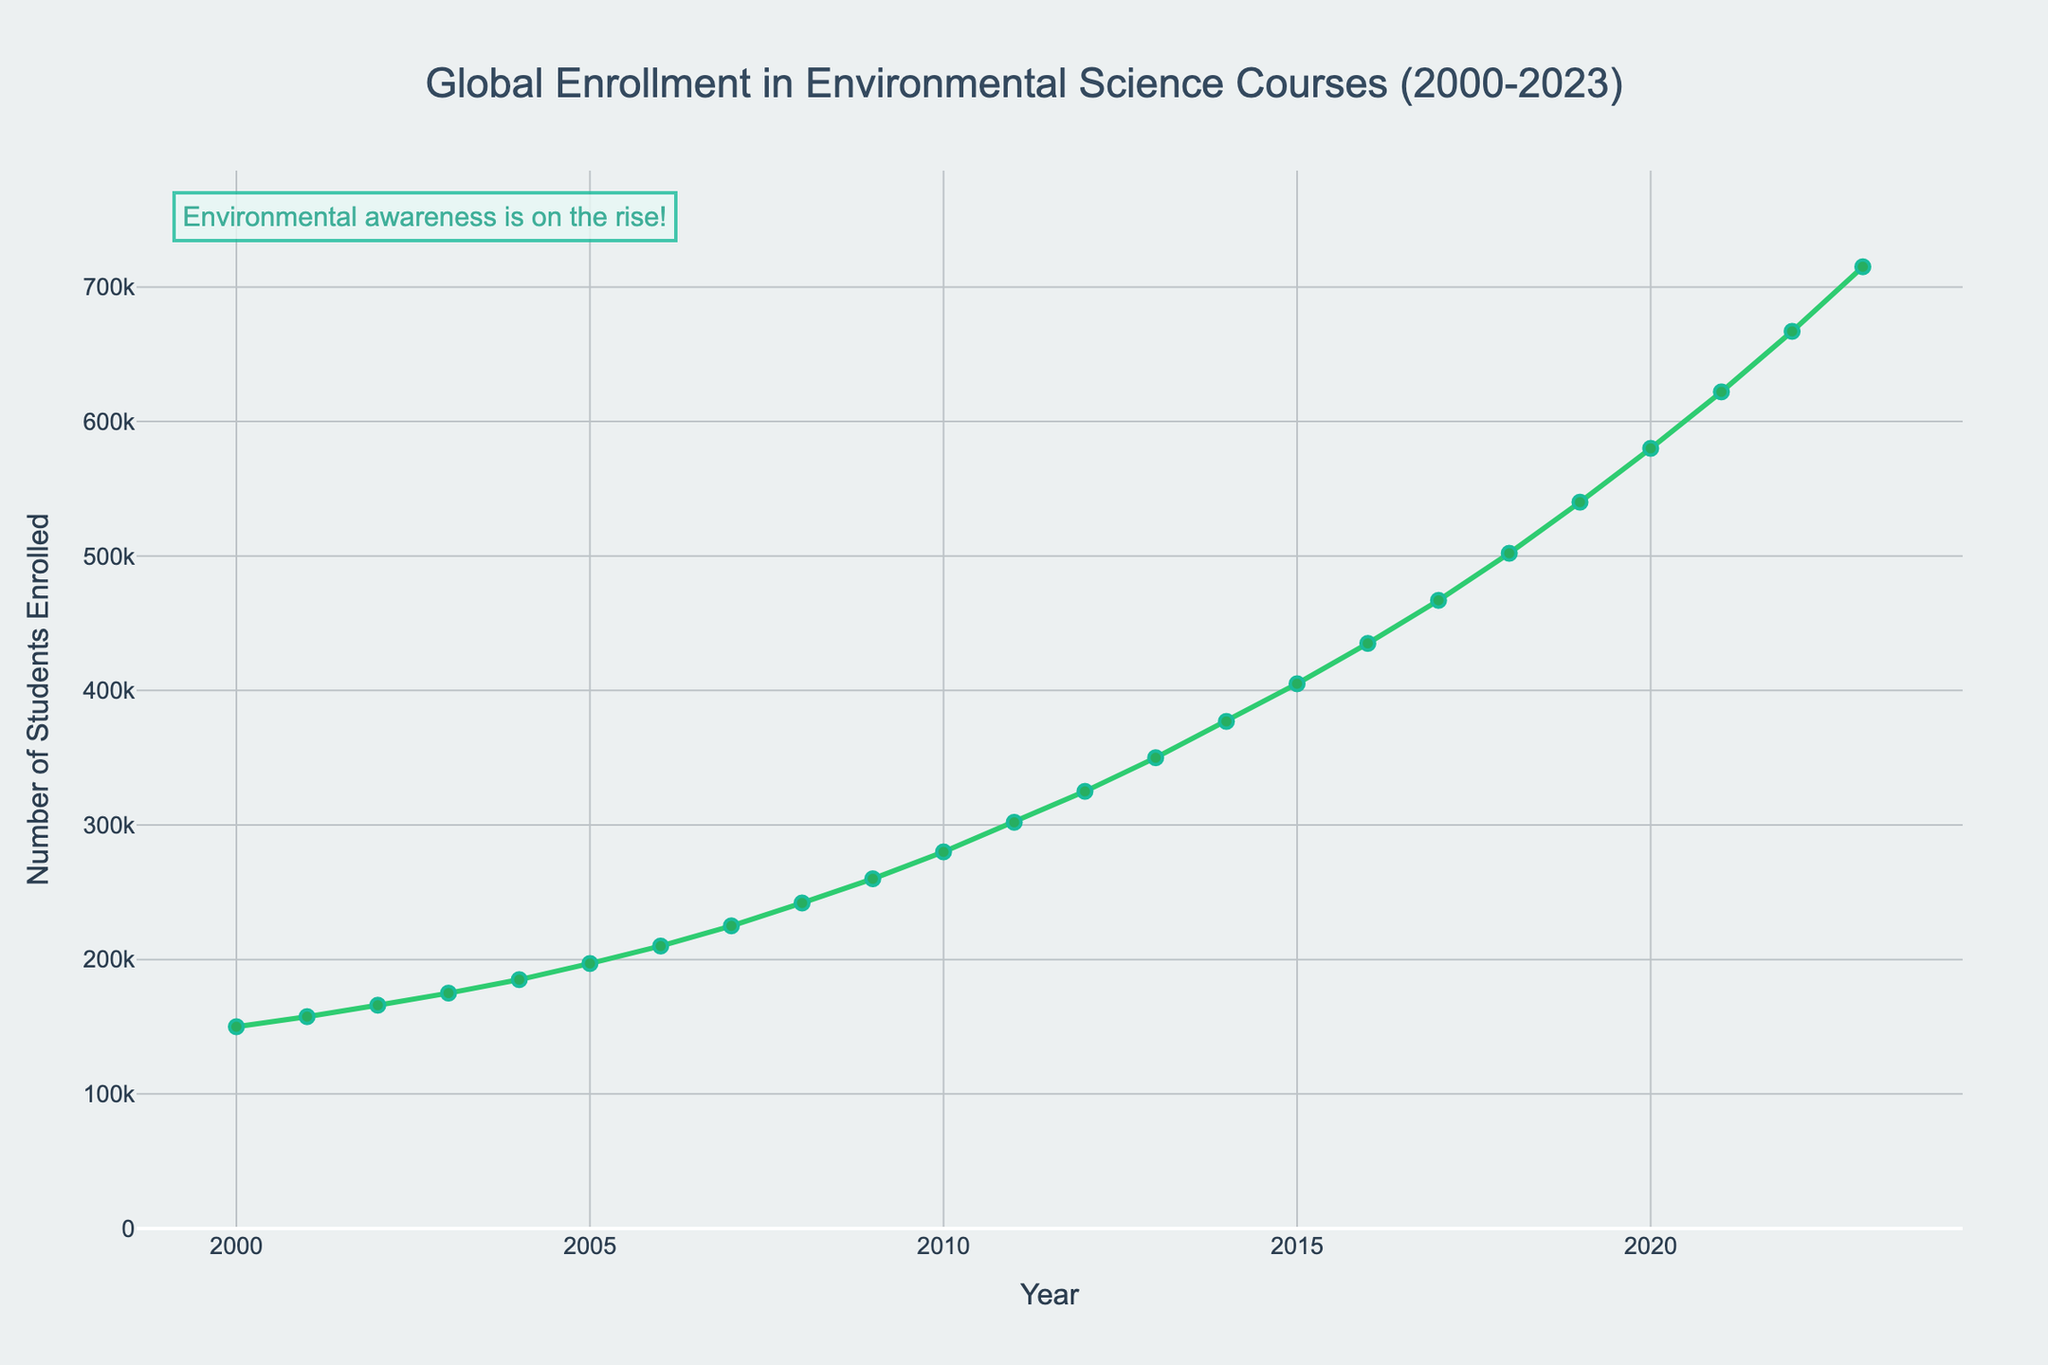What is the overall trend in global enrollment in environmental science courses from 2000 to 2023? The enrollment data shows a steady increase over the years from 2000 to 2023. Each year appears to show higher enrollment numbers compared to the previous year, indicating a consistent rising trend.
Answer: Steady increase What was the enrollment in environmental science courses in 2010? Locate the year 2010 on the x-axis and read the corresponding value on the y-axis, which represents the enrollment number. In 2010, the enrollment was indicated at 280,000 students.
Answer: 280,000 By how much did the global enrollment increase between the years 2010 and 2020? Subtract the enrollment figure of 2010 from that of 2020 to find the increase: 580,000 (2020) - 280,000 (2010) = 300,000.
Answer: 300,000 Between which consecutive years is the maximum increase in enrollment observed? Check the differences in enrollment numbers between consecutive years. The largest increase appears between 2022 (667,000) and 2023 (715,000), which is an increase of 48,000.
Answer: 2022-2023 How does the enrollment in 2005 compare to the enrollment in 2015? Compare the enrollment numbers for 2005 (197,000) and 2015 (405,000). The enrollment in 2015 is significantly higher.
Answer: 2015 is significantly higher What is the average enrollment for the first five years (2000-2004)? Sum the enrollment numbers for the first five years (150,000 + 157,500 + 166,000 + 175,000 + 185,000) and divide by 5: (833,500 / 5) = 166,700.
Answer: 166,700 Which year shows the first enrollment figure exceeding 500,000? Scan through the plot and locate when the y-axis value first crosses 500,000. This occurs in the year 2018, with an enrollment of 502,000.
Answer: 2018 How much did the enrollment change between 2000 and 2023? Subtract the enrollment in 2000 (150,000) from the enrollment in 2023 (715,000) to find the total change: 715,000 - 150,000 = 565,000.
Answer: 565,000 What was the enrollment increase from 2009 to 2010, and how does it compare to the increase from 2010 to 2011? Calculate the increases: from 2009 (260,000) to 2010 (280,000) is 20,000, and from 2010 (280,000) to 2011 (302,000) is 22,000. The increase from 2010 to 2011 is slightly larger.
Answer: 22,000 is slightly larger How does the visual annotation enhance the interpretation of the data? The annotation "Environmental awareness is on the rise!" highlights the increasing trend in enrollment, suggesting that rising environmental awareness may be driving the growth in student interest in environmental science courses.
Answer: Highlights increasing trend 